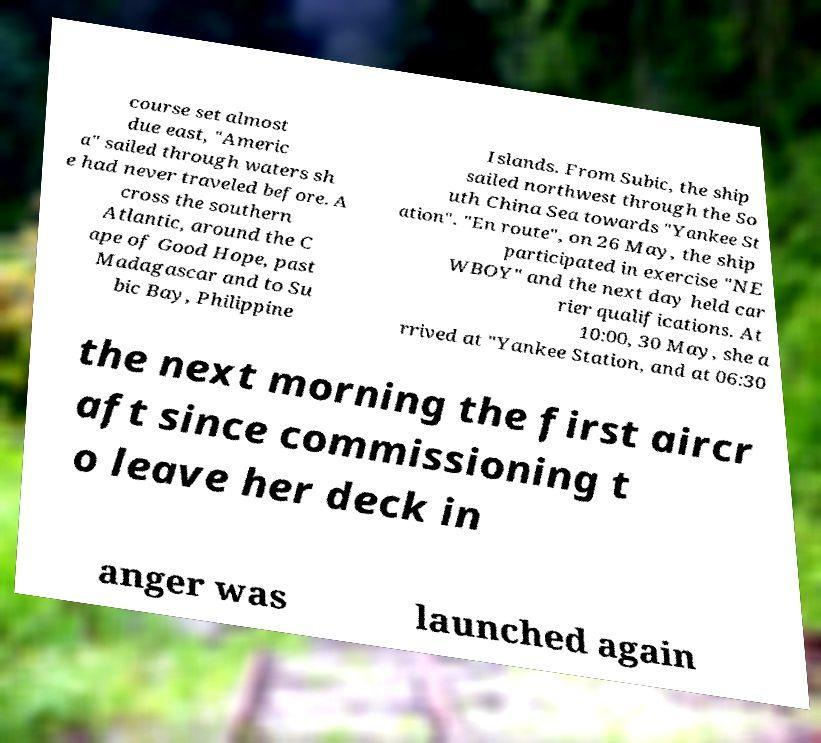Could you extract and type out the text from this image? course set almost due east, "Americ a" sailed through waters sh e had never traveled before. A cross the southern Atlantic, around the C ape of Good Hope, past Madagascar and to Su bic Bay, Philippine Islands. From Subic, the ship sailed northwest through the So uth China Sea towards "Yankee St ation". "En route", on 26 May, the ship participated in exercise "NE WBOY" and the next day held car rier qualifications. At 10:00, 30 May, she a rrived at "Yankee Station, and at 06:30 the next morning the first aircr aft since commissioning t o leave her deck in anger was launched again 